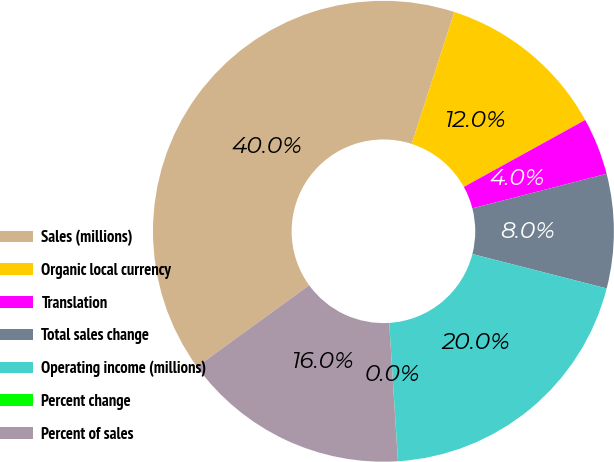Convert chart. <chart><loc_0><loc_0><loc_500><loc_500><pie_chart><fcel>Sales (millions)<fcel>Organic local currency<fcel>Translation<fcel>Total sales change<fcel>Operating income (millions)<fcel>Percent change<fcel>Percent of sales<nl><fcel>39.98%<fcel>12.0%<fcel>4.01%<fcel>8.0%<fcel>20.0%<fcel>0.01%<fcel>16.0%<nl></chart> 